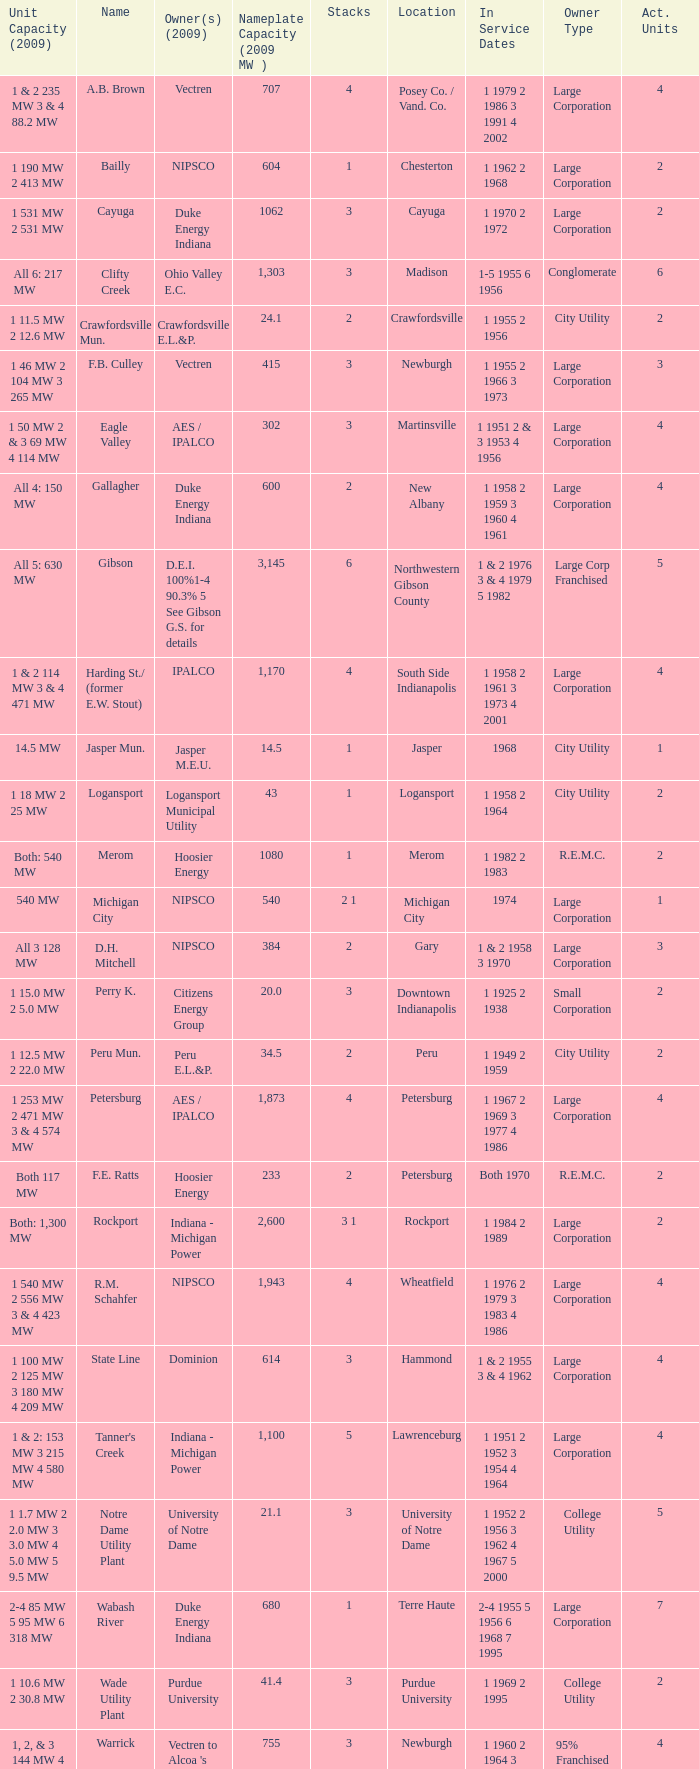Name the owners 2009 for south side indianapolis IPALCO. Would you mind parsing the complete table? {'header': ['Unit Capacity (2009)', 'Name', 'Owner(s) (2009)', 'Nameplate Capacity (2009 MW )', 'Stacks', 'Location', 'In Service Dates', 'Owner Type', 'Act. Units'], 'rows': [['1 & 2 235 MW 3 & 4 88.2 MW', 'A.B. Brown', 'Vectren', '707', '4', 'Posey Co. / Vand. Co.', '1 1979 2 1986 3 1991 4 2002', 'Large Corporation', '4'], ['1 190 MW 2 413 MW', 'Bailly', 'NIPSCO', '604', '1', 'Chesterton', '1 1962 2 1968', 'Large Corporation', '2'], ['1 531 MW 2 531 MW', 'Cayuga', 'Duke Energy Indiana', '1062', '3', 'Cayuga', '1 1970 2 1972', 'Large Corporation', '2'], ['All 6: 217 MW', 'Clifty Creek', 'Ohio Valley E.C.', '1,303', '3', 'Madison', '1-5 1955 6 1956', 'Conglomerate', '6'], ['1 11.5 MW 2 12.6 MW', 'Crawfordsville Mun.', 'Crawfordsville E.L.&P.', '24.1', '2', 'Crawfordsville', '1 1955 2 1956', 'City Utility', '2'], ['1 46 MW 2 104 MW 3 265 MW', 'F.B. Culley', 'Vectren', '415', '3', 'Newburgh', '1 1955 2 1966 3 1973', 'Large Corporation', '3'], ['1 50 MW 2 & 3 69 MW 4 114 MW', 'Eagle Valley', 'AES / IPALCO', '302', '3', 'Martinsville', '1 1951 2 & 3 1953 4 1956', 'Large Corporation', '4'], ['All 4: 150 MW', 'Gallagher', 'Duke Energy Indiana', '600', '2', 'New Albany', '1 1958 2 1959 3 1960 4 1961', 'Large Corporation', '4'], ['All 5: 630 MW', 'Gibson', 'D.E.I. 100%1-4 90.3% 5 See Gibson G.S. for details', '3,145', '6', 'Northwestern Gibson County', '1 & 2 1976 3 & 4 1979 5 1982', 'Large Corp Franchised', '5'], ['1 & 2 114 MW 3 & 4 471 MW', 'Harding St./ (former E.W. Stout)', 'IPALCO', '1,170', '4', 'South Side Indianapolis', '1 1958 2 1961 3 1973 4 2001', 'Large Corporation', '4'], ['14.5 MW', 'Jasper Mun.', 'Jasper M.E.U.', '14.5', '1', 'Jasper', '1968', 'City Utility', '1'], ['1 18 MW 2 25 MW', 'Logansport', 'Logansport Municipal Utility', '43', '1', 'Logansport', '1 1958 2 1964', 'City Utility', '2'], ['Both: 540 MW', 'Merom', 'Hoosier Energy', '1080', '1', 'Merom', '1 1982 2 1983', 'R.E.M.C.', '2'], ['540 MW', 'Michigan City', 'NIPSCO', '540', '2 1', 'Michigan City', '1974', 'Large Corporation', '1'], ['All 3 128 MW', 'D.H. Mitchell', 'NIPSCO', '384', '2', 'Gary', '1 & 2 1958 3 1970', 'Large Corporation', '3'], ['1 15.0 MW 2 5.0 MW', 'Perry K.', 'Citizens Energy Group', '20.0', '3', 'Downtown Indianapolis', '1 1925 2 1938', 'Small Corporation', '2'], ['1 12.5 MW 2 22.0 MW', 'Peru Mun.', 'Peru E.L.&P.', '34.5', '2', 'Peru', '1 1949 2 1959', 'City Utility', '2'], ['1 253 MW 2 471 MW 3 & 4 574 MW', 'Petersburg', 'AES / IPALCO', '1,873', '4', 'Petersburg', '1 1967 2 1969 3 1977 4 1986', 'Large Corporation', '4'], ['Both 117 MW', 'F.E. Ratts', 'Hoosier Energy', '233', '2', 'Petersburg', 'Both 1970', 'R.E.M.C.', '2'], ['Both: 1,300 MW', 'Rockport', 'Indiana - Michigan Power', '2,600', '3 1', 'Rockport', '1 1984 2 1989', 'Large Corporation', '2'], ['1 540 MW 2 556 MW 3 & 4 423 MW', 'R.M. Schahfer', 'NIPSCO', '1,943', '4', 'Wheatfield', '1 1976 2 1979 3 1983 4 1986', 'Large Corporation', '4'], ['1 100 MW 2 125 MW 3 180 MW 4 209 MW', 'State Line', 'Dominion', '614', '3', 'Hammond', '1 & 2 1955 3 & 4 1962', 'Large Corporation', '4'], ['1 & 2: 153 MW 3 215 MW 4 580 MW', "Tanner's Creek", 'Indiana - Michigan Power', '1,100', '5', 'Lawrenceburg', '1 1951 2 1952 3 1954 4 1964', 'Large Corporation', '4'], ['1 1.7 MW 2 2.0 MW 3 3.0 MW 4 5.0 MW 5 9.5 MW', 'Notre Dame Utility Plant', 'University of Notre Dame', '21.1', '3', 'University of Notre Dame', '1 1952 2 1956 3 1962 4 1967 5 2000', 'College Utility', '5'], ['2-4 85 MW 5 95 MW 6 318 MW', 'Wabash River', 'Duke Energy Indiana', '680', '1', 'Terre Haute', '2-4 1955 5 1956 6 1968 7 1995', 'Large Corporation', '7'], ['1 10.6 MW 2 30.8 MW', 'Wade Utility Plant', 'Purdue University', '41.4', '3', 'Purdue University', '1 1969 2 1995', 'College Utility', '2'], ['1, 2, & 3 144 MW 4 323 MW', 'Warrick', "Vectren to Alcoa 's Newburgh Smelter", '755', '3', 'Newburgh', '1 1960 2 1964 3 1965 4 1970', '95% Franchised', '4']]} 